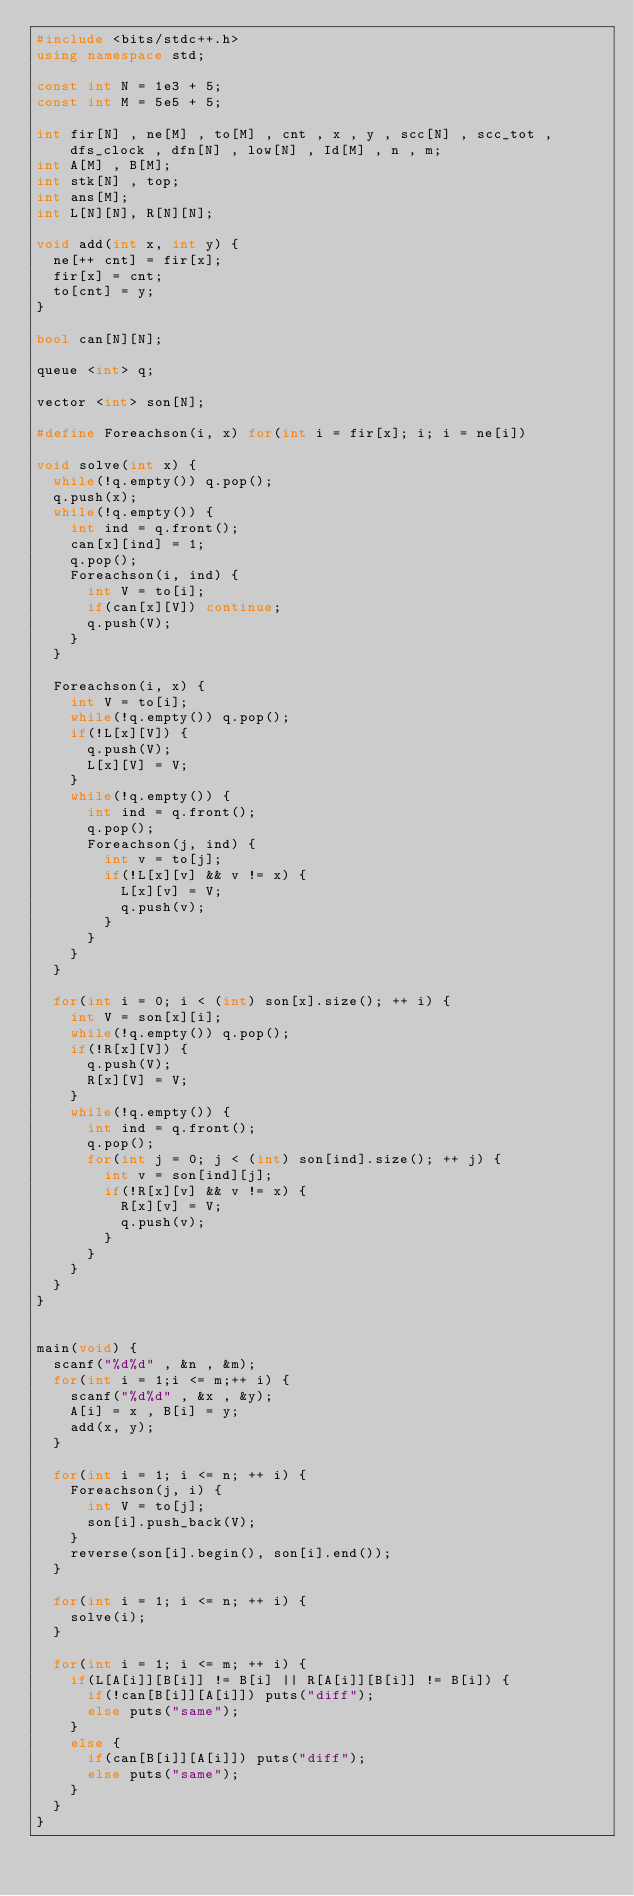Convert code to text. <code><loc_0><loc_0><loc_500><loc_500><_C++_>#include <bits/stdc++.h>
using namespace std;
 
const int N = 1e3 + 5;
const int M = 5e5 + 5;
 
int fir[N] , ne[M] , to[M] , cnt , x , y , scc[N] , scc_tot , dfs_clock , dfn[N] , low[N] , Id[M] , n , m;
int A[M] , B[M];
int stk[N] , top;
int ans[M];
int L[N][N], R[N][N];

void add(int x, int y) {
	ne[++ cnt] = fir[x];
	fir[x] = cnt;
	to[cnt] = y;
}

bool can[N][N];

queue <int> q;

vector <int> son[N];

#define Foreachson(i, x) for(int i = fir[x]; i; i = ne[i])

void solve(int x) {
	while(!q.empty()) q.pop();
	q.push(x);
	while(!q.empty()) {
		int ind = q.front();
		can[x][ind] = 1;
		q.pop();
		Foreachson(i, ind) {
			int V = to[i];
			if(can[x][V]) continue;
			q.push(V);
		}
	}
	
	Foreachson(i, x) {
		int V = to[i];
		while(!q.empty()) q.pop();
		if(!L[x][V]) {
			q.push(V);
			L[x][V] = V;
		}
		while(!q.empty()) {
			int ind = q.front();
			q.pop();
			Foreachson(j, ind) {
				int v = to[j];
				if(!L[x][v] && v != x) {
					L[x][v] = V;
					q.push(v);
				}
			}
		}
	}
	
	for(int i = 0; i < (int) son[x].size(); ++ i) {
		int V = son[x][i];
		while(!q.empty()) q.pop();
		if(!R[x][V]) {
			q.push(V);
			R[x][V] = V;
		}
		while(!q.empty()) {
			int ind = q.front();
			q.pop();
			for(int j = 0; j < (int) son[ind].size(); ++ j) {
				int v = son[ind][j];
				if(!R[x][v] && v != x) {
					R[x][v] = V;
					q.push(v);
				}
			}
		}
	}
}

 
main(void) {
	scanf("%d%d" , &n , &m);
	for(int i = 1;i <= m;++ i) {
		scanf("%d%d" , &x , &y);
		A[i] = x , B[i] = y;
		add(x, y);
	}
	
	for(int i = 1; i <= n; ++ i) {
		Foreachson(j, i) {
			int V = to[j];
			son[i].push_back(V);
		}
		reverse(son[i].begin(), son[i].end());
	}
	
	for(int i = 1; i <= n; ++ i) {
		solve(i);
	}
	
	for(int i = 1; i <= m; ++ i) {
		if(L[A[i]][B[i]] != B[i] || R[A[i]][B[i]] != B[i]) {
			if(!can[B[i]][A[i]]) puts("diff");
			else puts("same");
		}
		else {
			if(can[B[i]][A[i]]) puts("diff");
			else puts("same");
		}
	}
}</code> 